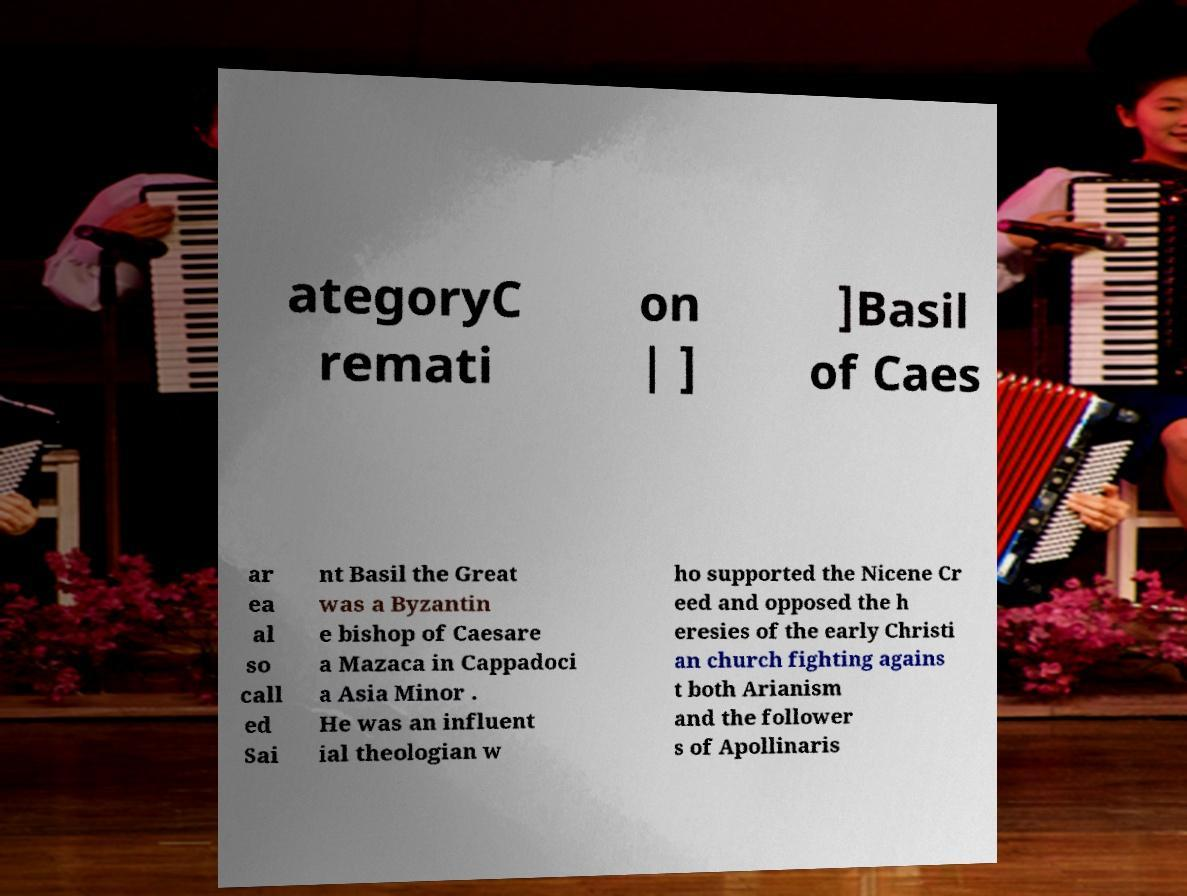For documentation purposes, I need the text within this image transcribed. Could you provide that? ategoryC remati on | ] ]Basil of Caes ar ea al so call ed Sai nt Basil the Great was a Byzantin e bishop of Caesare a Mazaca in Cappadoci a Asia Minor . He was an influent ial theologian w ho supported the Nicene Cr eed and opposed the h eresies of the early Christi an church fighting agains t both Arianism and the follower s of Apollinaris 